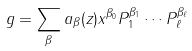Convert formula to latex. <formula><loc_0><loc_0><loc_500><loc_500>g = \sum _ { \beta } a _ { \beta } ( z ) x ^ { \beta _ { 0 } } P _ { 1 } ^ { \beta _ { 1 } } \cdots P _ { \ell } ^ { \beta _ { \ell } }</formula> 